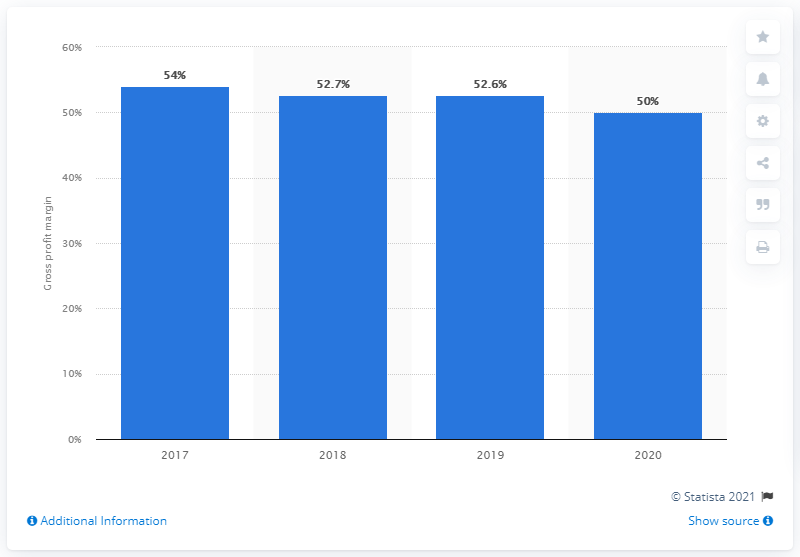Draw attention to some important aspects in this diagram. The global gross profit margin of the H&M Group in fiscal year 2020 was 50%. 